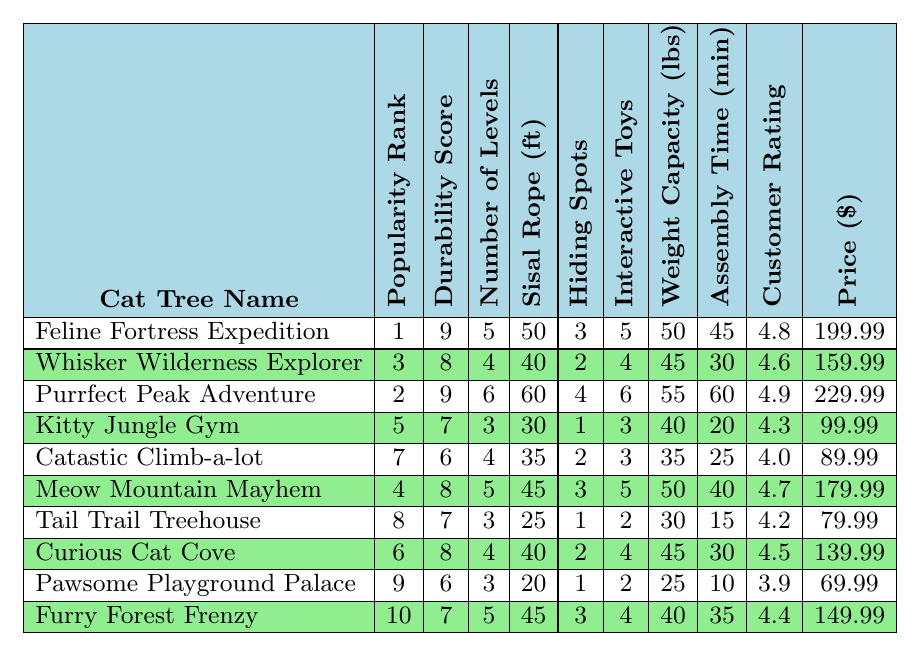What is the durability score of "Feline Fortress Expedition"? The durability score is listed in the table next to the corresponding cat tree name. For "Feline Fortress Expedition," the durability score is 9.
Answer: 9 Which cat tree has the highest customer rating? By checking the customer ratings in the table, the highest rating is associated with "Purrfect Peak Adventure," which has a customer rating of 4.9.
Answer: Purrfect Peak Adventure What is the average price of all the cat trees? First, sum the prices of all cat trees: (199.99 + 159.99 + 229.99 + 99.99 + 89.99 + 179.99 + 79.99 + 139.99 + 69.99 + 149.99) = 1,394.90. Then divide by the number of cat trees (10): 1,394.90 / 10 = 139.49.
Answer: 139.49 How many cat trees have a durability score that is 8 or higher? Reviewing the durability scores in the table, there are five cat trees with durability scores of 8 or higher: "Feline Fortress Expedition," "Whisker Wilderness Explorer," "Meow Mountain Mayhem," "Curious Cat Cove," and "Purrfect Peak Adventure."
Answer: 5 What is the price difference between the least and most popular cat trees? The least popular cat tree is "Furry Forest Frenzy" with a popularity rank of 10 and costs $149.99. The most popular is "Feline Fortress Expedition" ranked 1 and costs $199.99. The price difference is $199.99 - $149.99 = $50.00.
Answer: $50.00 Which cat tree has the most interactive toys, and what is that number? The table indicates that "Purrfect Peak Adventure" has the most interactive toys with a total of 6.
Answer: 6 Is there a cat tree that has more than 5 levels? By checking the table, "Purrfect Peak Adventure" has 6 levels, confirming that there is indeed a cat tree with more than 5 levels.
Answer: Yes What is the weight capacity of the cat tree ranked 4th in popularity? The 4th ranked cat tree is "Meow Mountain Mayhem," which has a weight capacity of 50 lbs as shown in the table next to its ranking.
Answer: 50 lbs Calculate the median durability score of the cat trees. Listing the durability scores in order: 6, 6, 7, 7, 7, 8, 8, 8, 9, 9, the median is the average of the 5th and 6th scores: (7 + 8) / 2 = 7.5.
Answer: 7.5 Which cat tree has the least amount of hiding spots? The table shows that both "Kitty Jungle Gym" and "Tail Trail Treehouse" have 1 hiding spot, making them the cat trees with the least amount of hiding spots.
Answer: Kitty Jungle Gym and Tail Trail Treehouse 